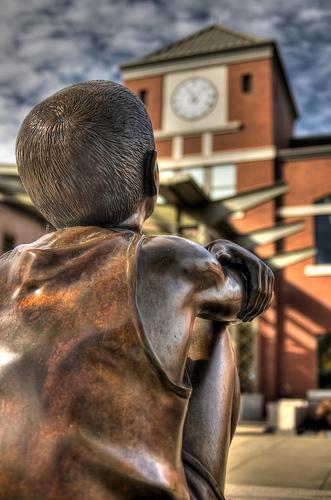How many windows are visible in the top of the tower?
Give a very brief answer. 3. How many clocks are pictured?
Give a very brief answer. 1. 